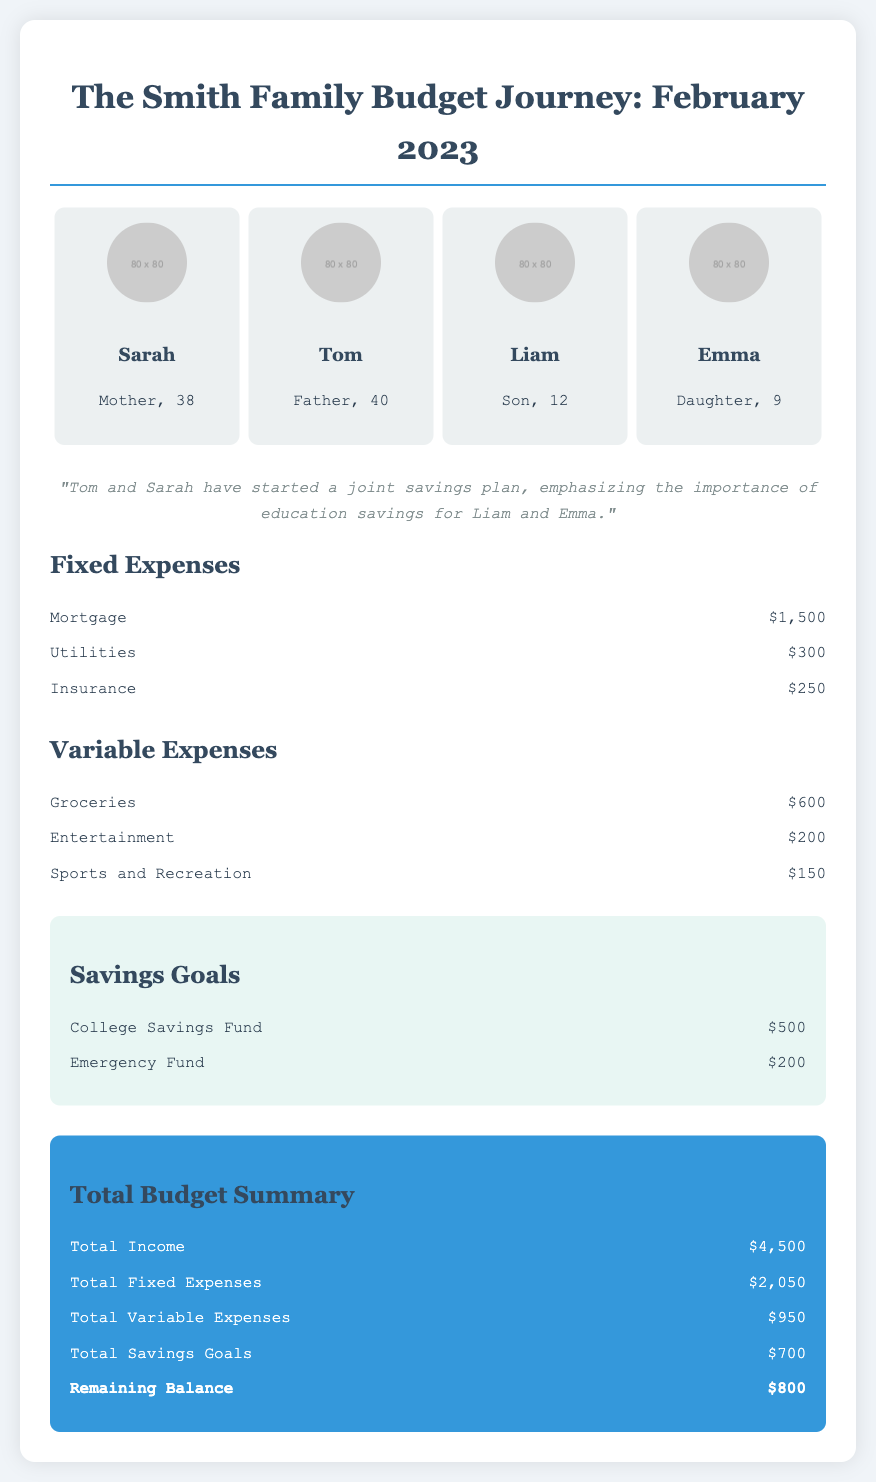What is the total income for February 2023? The total income is listed in the budget summary section and is stated as $4,500.
Answer: $4,500 How much does the Smith family allocate for groceries? The grocery expense is detailed under variable expenses, amounting to $600.
Answer: $600 What is Tom and Sarah's new financial initiative? The relationship changes section mentions their joint savings plan focusing on education savings.
Answer: Joint savings plan What is the amount set aside for the Emergency Fund? The savings goals section specifies $200 allocated for the Emergency Fund.
Answer: $200 What is the remaining balance after expenses and savings? The remaining balance is calculated in the total budget summary, which shows $800.
Answer: $800 What percentage of their total income is spent on fixed expenses? Fixed expenses total $2,050, which is approximately 45.56% of the total income of $4,500.
Answer: 45.56% How much is set aside for the College Savings Fund? The budget clearly lists $500 designated for the College Savings Fund.
Answer: $500 What is the total amount spent on entertainment? The entertainment expense is listed under variable expenses and totals $200.
Answer: $200 How many family members are in the Smith family? The document presents four family members in the family members section.
Answer: Four 